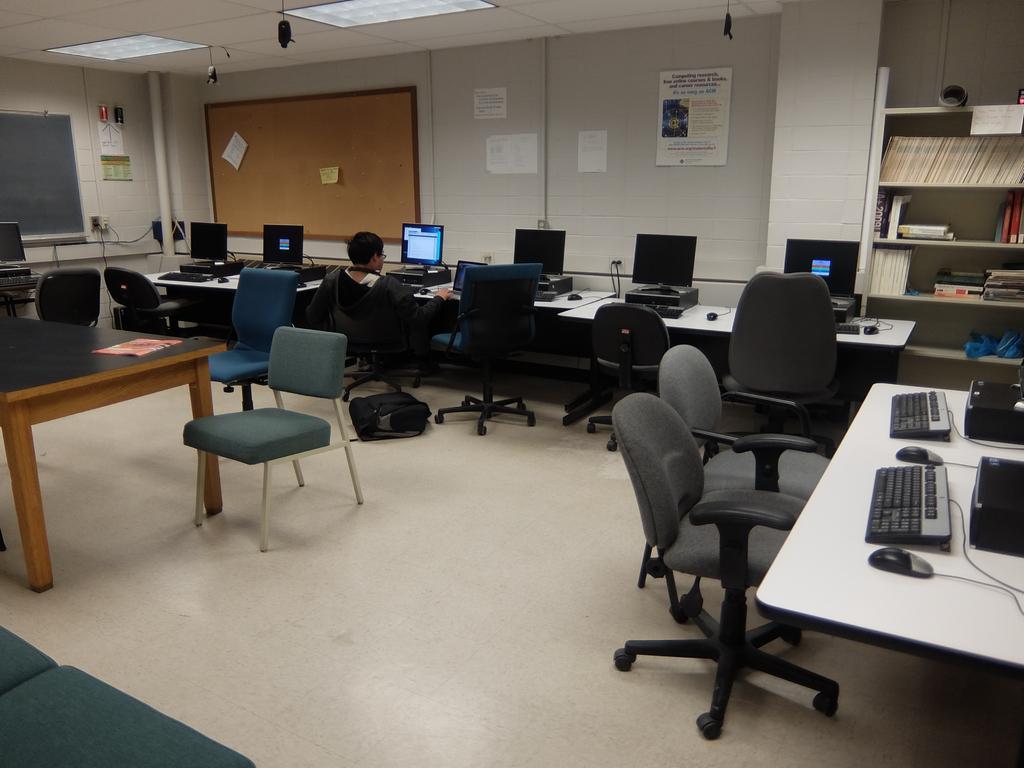Please provide a concise description of this image. In this image we can see chairs and this person is sitting on the chair. Here we can see the bag on the floor. Here we can see the tables upon which we can see monitors, keyboards and mouses. In the background, we can see board, posters on the wall, books and few things kept in the shelf and the ceiling with the lights. 